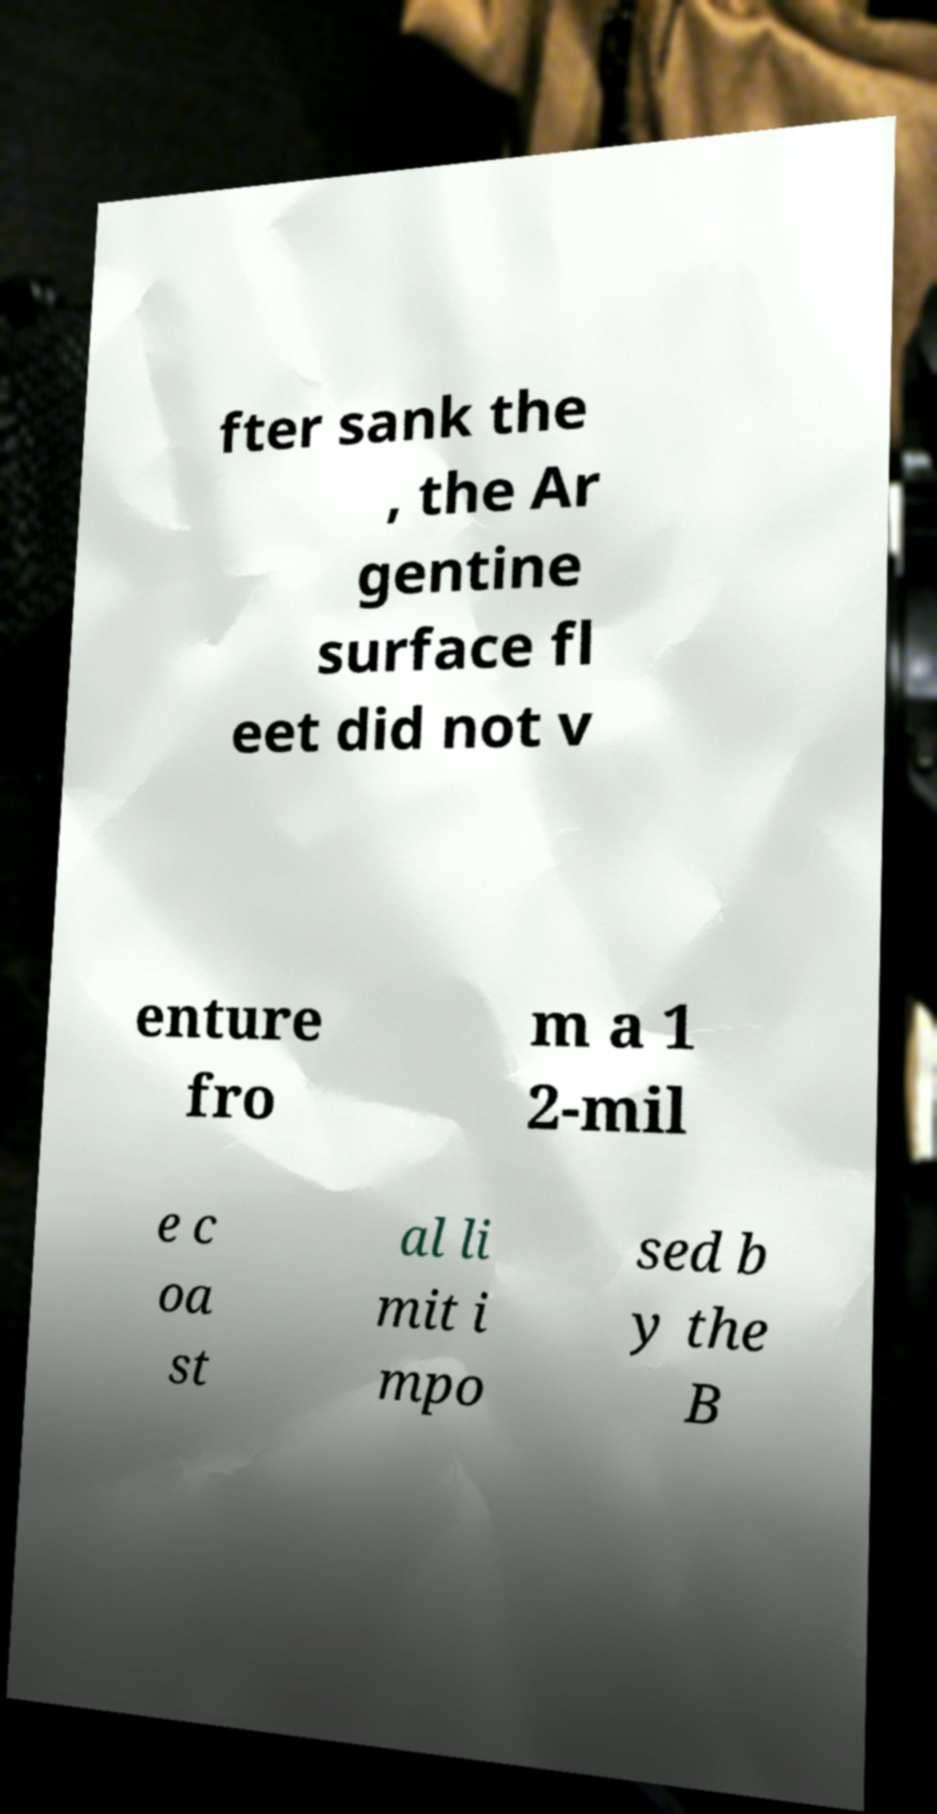What messages or text are displayed in this image? I need them in a readable, typed format. fter sank the , the Ar gentine surface fl eet did not v enture fro m a 1 2-mil e c oa st al li mit i mpo sed b y the B 